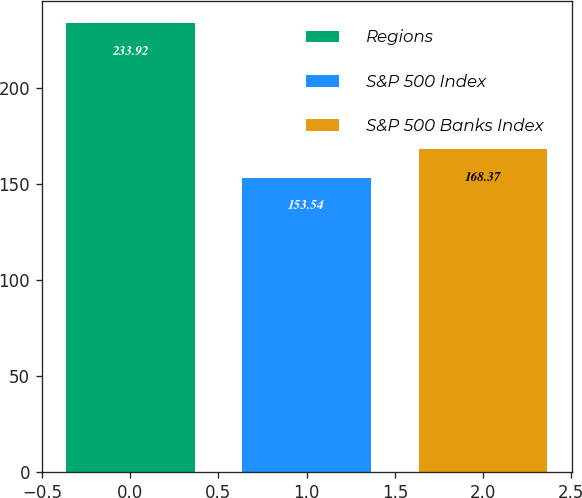Convert chart. <chart><loc_0><loc_0><loc_500><loc_500><bar_chart><fcel>Regions<fcel>S&P 500 Index<fcel>S&P 500 Banks Index<nl><fcel>233.92<fcel>153.54<fcel>168.37<nl></chart> 